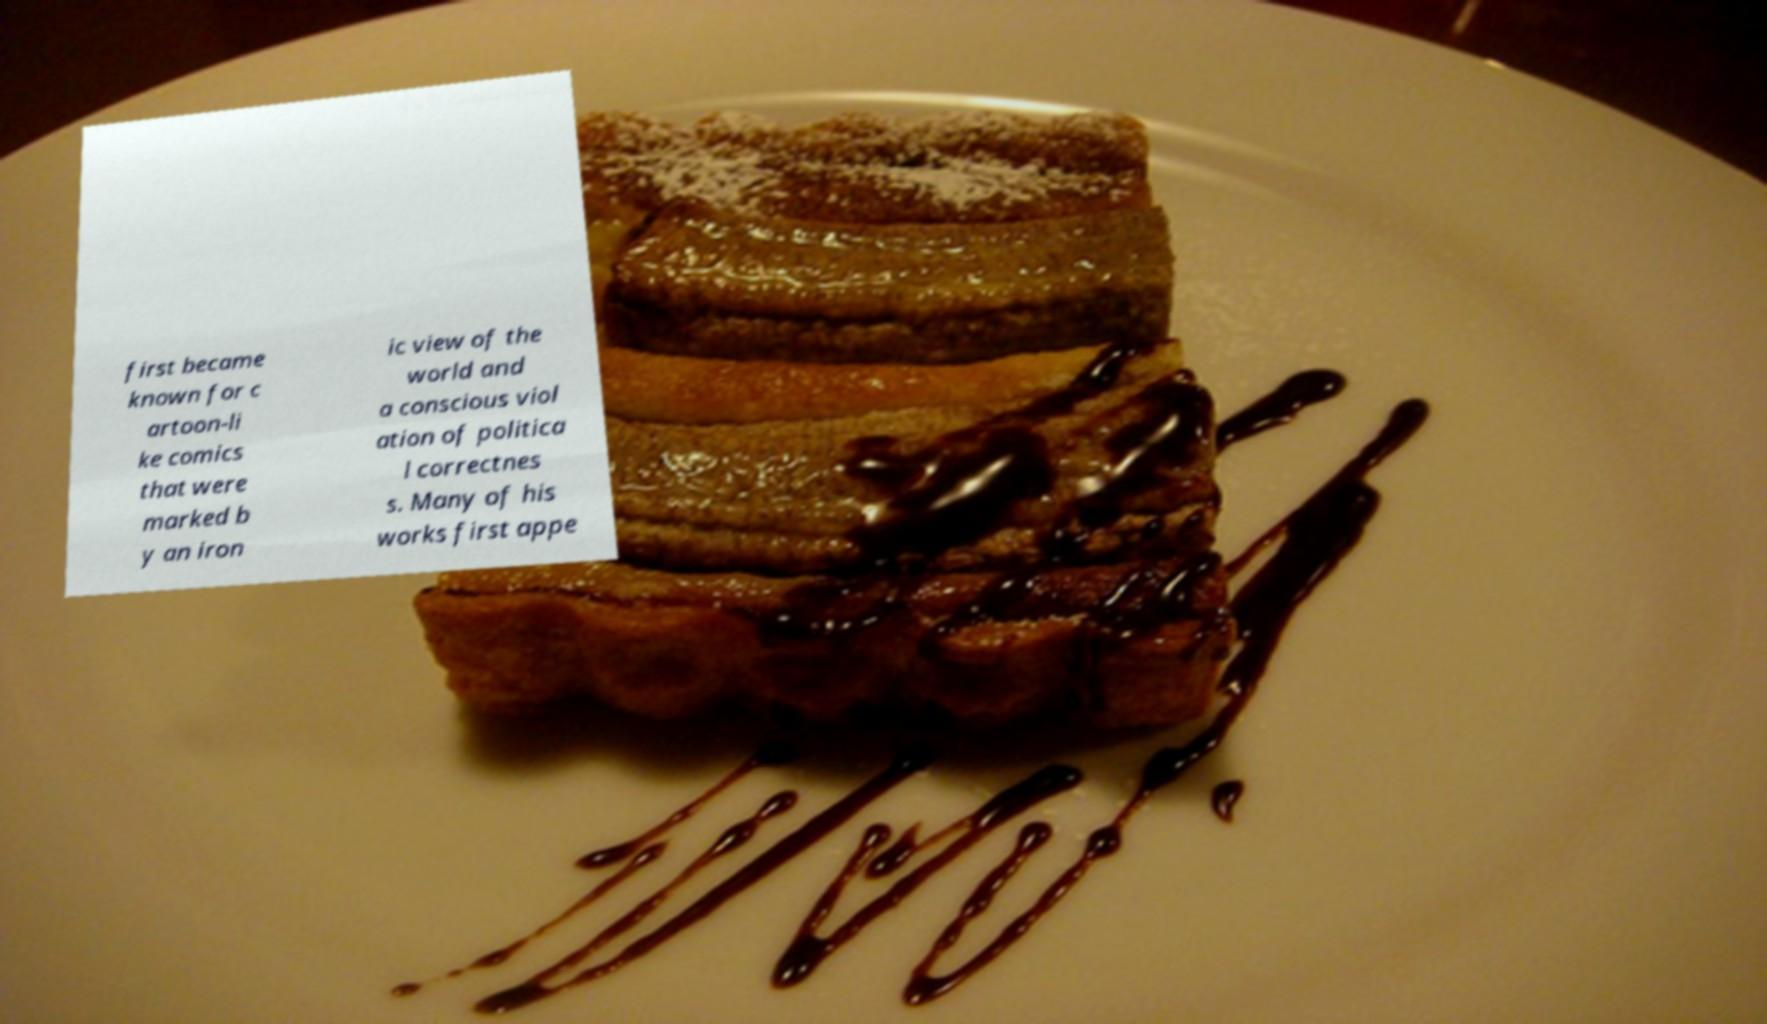There's text embedded in this image that I need extracted. Can you transcribe it verbatim? first became known for c artoon-li ke comics that were marked b y an iron ic view of the world and a conscious viol ation of politica l correctnes s. Many of his works first appe 